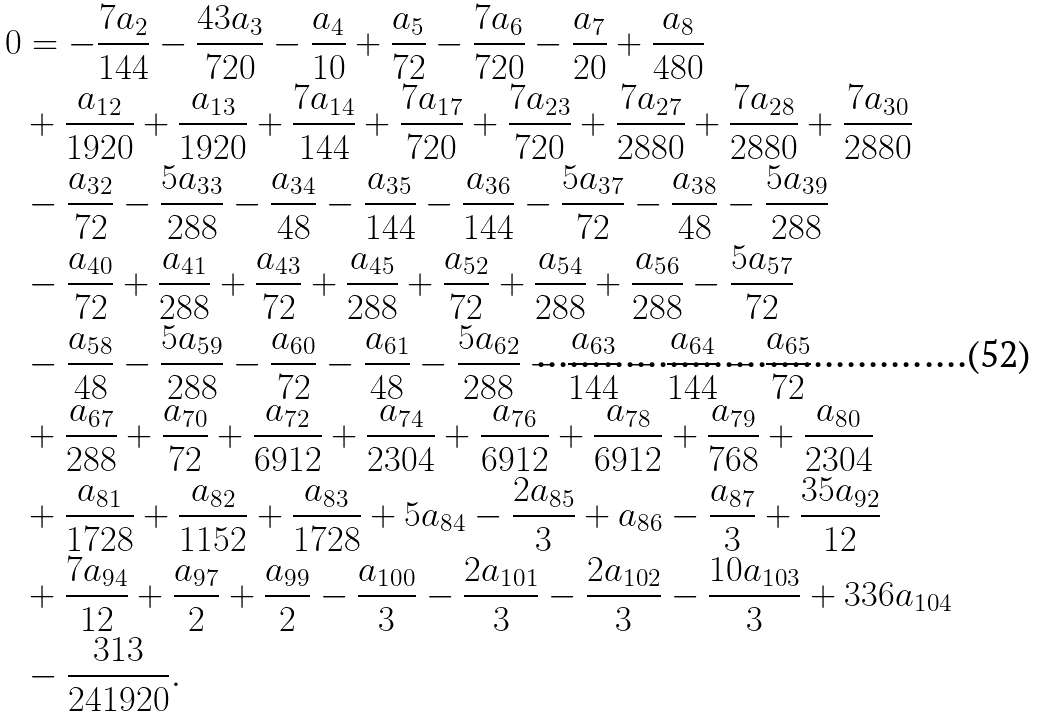<formula> <loc_0><loc_0><loc_500><loc_500>0 & = - \frac { 7 a _ { 2 } } { 1 4 4 } - \frac { 4 3 a _ { 3 } } { 7 2 0 } - \frac { a _ { 4 } } { 1 0 } + \frac { a _ { 5 } } { 7 2 } - \frac { 7 a _ { 6 } } { 7 2 0 } - \frac { a _ { 7 } } { 2 0 } + \frac { a _ { 8 } } { 4 8 0 } \\ & + \frac { a _ { 1 2 } } { 1 9 2 0 } + \frac { a _ { 1 3 } } { 1 9 2 0 } + \frac { 7 a _ { 1 4 } } { 1 4 4 } + \frac { 7 a _ { 1 7 } } { 7 2 0 } + \frac { 7 a _ { 2 3 } } { 7 2 0 } + \frac { 7 a _ { 2 7 } } { 2 8 8 0 } + \frac { 7 a _ { 2 8 } } { 2 8 8 0 } + \frac { 7 a _ { 3 0 } } { 2 8 8 0 } \\ & - \frac { a _ { 3 2 } } { 7 2 } - \frac { 5 a _ { 3 3 } } { 2 8 8 } - \frac { a _ { 3 4 } } { 4 8 } - \frac { a _ { 3 5 } } { 1 4 4 } - \frac { a _ { 3 6 } } { 1 4 4 } - \frac { 5 a _ { 3 7 } } { 7 2 } - \frac { a _ { 3 8 } } { 4 8 } - \frac { 5 a _ { 3 9 } } { 2 8 8 } \\ & - \frac { a _ { 4 0 } } { 7 2 } + \frac { a _ { 4 1 } } { 2 8 8 } + \frac { a _ { 4 3 } } { 7 2 } + \frac { a _ { 4 5 } } { 2 8 8 } + \frac { a _ { 5 2 } } { 7 2 } + \frac { a _ { 5 4 } } { 2 8 8 } + \frac { a _ { 5 6 } } { 2 8 8 } - \frac { 5 a _ { 5 7 } } { 7 2 } \\ & - \frac { a _ { 5 8 } } { 4 8 } - \frac { 5 a _ { 5 9 } } { 2 8 8 } - \frac { a _ { 6 0 } } { 7 2 } - \frac { a _ { 6 1 } } { 4 8 } - \frac { 5 a _ { 6 2 } } { 2 8 8 } - \frac { a _ { 6 3 } } { 1 4 4 } - \frac { a _ { 6 4 } } { 1 4 4 } - \frac { a _ { 6 5 } } { 7 2 } \\ & + \frac { a _ { 6 7 } } { 2 8 8 } + \frac { a _ { 7 0 } } { 7 2 } + \frac { a _ { 7 2 } } { 6 9 1 2 } + \frac { a _ { 7 4 } } { 2 3 0 4 } + \frac { a _ { 7 6 } } { 6 9 1 2 } + \frac { a _ { 7 8 } } { 6 9 1 2 } + \frac { a _ { 7 9 } } { 7 6 8 } + \frac { a _ { 8 0 } } { 2 3 0 4 } \\ & + \frac { a _ { 8 1 } } { 1 7 2 8 } + \frac { a _ { 8 2 } } { 1 1 5 2 } + \frac { a _ { 8 3 } } { 1 7 2 8 } + 5 a _ { 8 4 } - \frac { 2 a _ { 8 5 } } { 3 } + a _ { 8 6 } - \frac { a _ { 8 7 } } { 3 } + \frac { 3 5 a _ { 9 2 } } { 1 2 } \\ & + \frac { 7 a _ { 9 4 } } { 1 2 } + \frac { a _ { 9 7 } } { 2 } + \frac { a _ { 9 9 } } { 2 } - \frac { a _ { 1 0 0 } } { 3 } - \frac { 2 a _ { 1 0 1 } } { 3 } - \frac { 2 a _ { 1 0 2 } } { 3 } - \frac { 1 0 a _ { 1 0 3 } } { 3 } + 3 3 6 a _ { 1 0 4 } \\ & - \frac { 3 1 3 } { 2 4 1 9 2 0 } .</formula> 